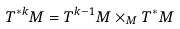Convert formula to latex. <formula><loc_0><loc_0><loc_500><loc_500>T ^ { * k } M = T ^ { k - 1 } M \times _ { M } T ^ { * } M</formula> 